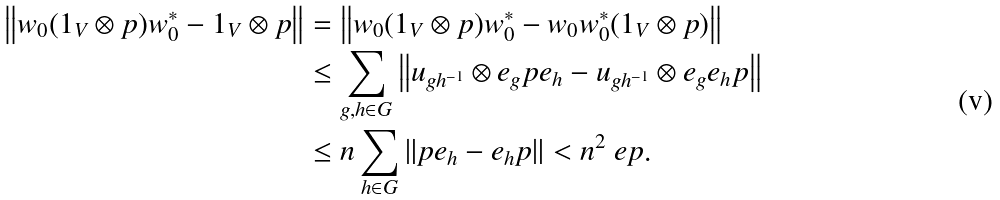<formula> <loc_0><loc_0><loc_500><loc_500>\left \| w _ { 0 } ( 1 _ { V } \otimes p ) w _ { 0 } ^ { * } - 1 _ { V } \otimes p \right \| & = \left \| w _ { 0 } ( 1 _ { V } \otimes p ) w _ { 0 } ^ { * } - w _ { 0 } w _ { 0 } ^ { * } ( 1 _ { V } \otimes p ) \right \| \\ & \leq \sum _ { g , h \in G } \left \| u _ { g h ^ { - 1 } } \otimes e _ { g } p e _ { h } - u _ { g h ^ { - 1 } } \otimes e _ { g } e _ { h } p \right \| \\ & \leq n \sum _ { h \in G } \| p e _ { h } - e _ { h } p \| < n ^ { 2 } \ e p .</formula> 